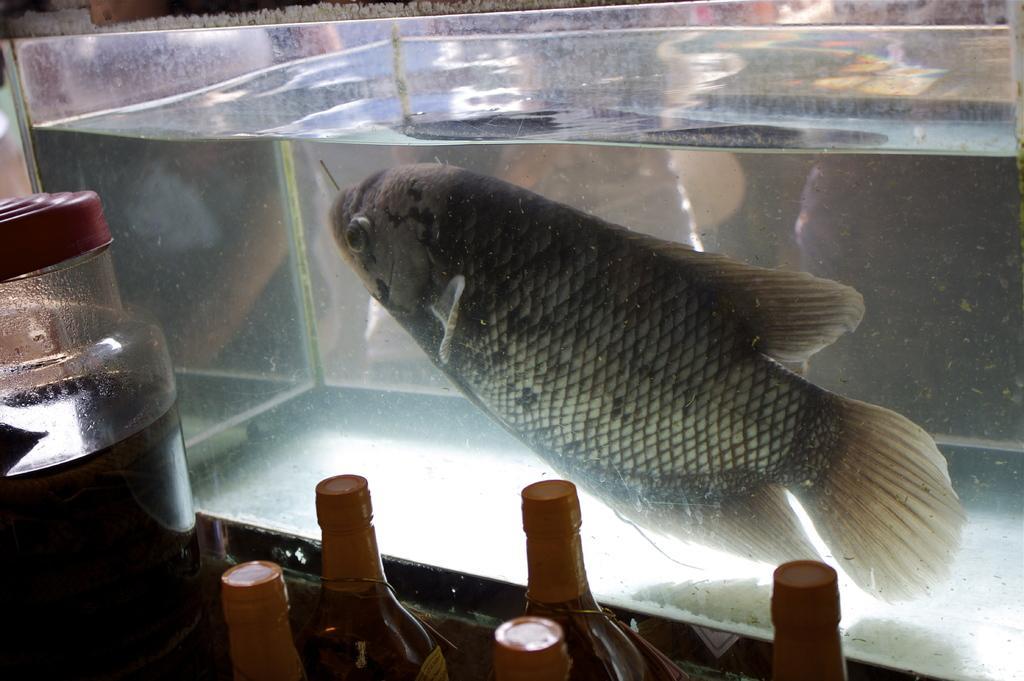Please provide a concise description of this image. We can able to see bottles, jar and aquarium. In this aquarium there is a fish and water. 